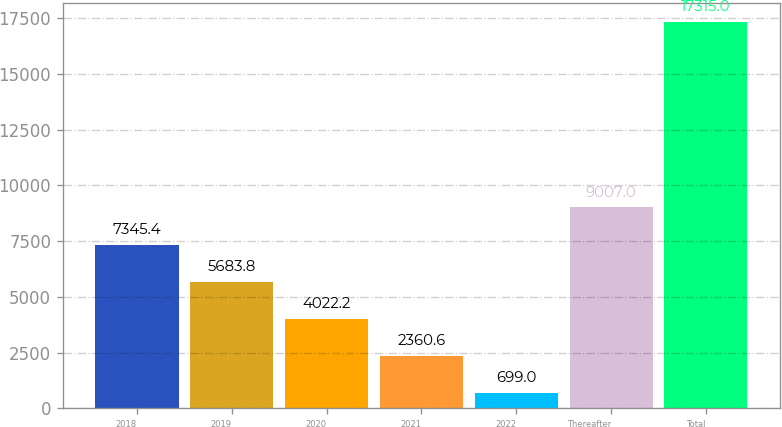<chart> <loc_0><loc_0><loc_500><loc_500><bar_chart><fcel>2018<fcel>2019<fcel>2020<fcel>2021<fcel>2022<fcel>Thereafter<fcel>Total<nl><fcel>7345.4<fcel>5683.8<fcel>4022.2<fcel>2360.6<fcel>699<fcel>9007<fcel>17315<nl></chart> 